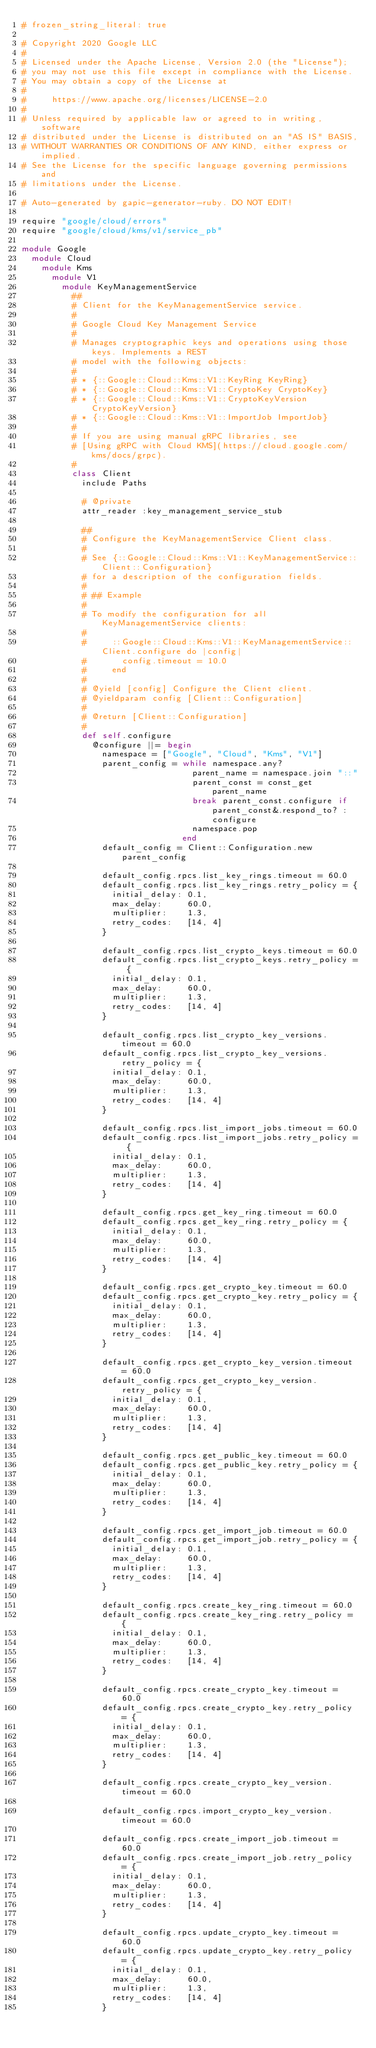<code> <loc_0><loc_0><loc_500><loc_500><_Ruby_># frozen_string_literal: true

# Copyright 2020 Google LLC
#
# Licensed under the Apache License, Version 2.0 (the "License");
# you may not use this file except in compliance with the License.
# You may obtain a copy of the License at
#
#     https://www.apache.org/licenses/LICENSE-2.0
#
# Unless required by applicable law or agreed to in writing, software
# distributed under the License is distributed on an "AS IS" BASIS,
# WITHOUT WARRANTIES OR CONDITIONS OF ANY KIND, either express or implied.
# See the License for the specific language governing permissions and
# limitations under the License.

# Auto-generated by gapic-generator-ruby. DO NOT EDIT!

require "google/cloud/errors"
require "google/cloud/kms/v1/service_pb"

module Google
  module Cloud
    module Kms
      module V1
        module KeyManagementService
          ##
          # Client for the KeyManagementService service.
          #
          # Google Cloud Key Management Service
          #
          # Manages cryptographic keys and operations using those keys. Implements a REST
          # model with the following objects:
          #
          # * {::Google::Cloud::Kms::V1::KeyRing KeyRing}
          # * {::Google::Cloud::Kms::V1::CryptoKey CryptoKey}
          # * {::Google::Cloud::Kms::V1::CryptoKeyVersion CryptoKeyVersion}
          # * {::Google::Cloud::Kms::V1::ImportJob ImportJob}
          #
          # If you are using manual gRPC libraries, see
          # [Using gRPC with Cloud KMS](https://cloud.google.com/kms/docs/grpc).
          #
          class Client
            include Paths

            # @private
            attr_reader :key_management_service_stub

            ##
            # Configure the KeyManagementService Client class.
            #
            # See {::Google::Cloud::Kms::V1::KeyManagementService::Client::Configuration}
            # for a description of the configuration fields.
            #
            # ## Example
            #
            # To modify the configuration for all KeyManagementService clients:
            #
            #     ::Google::Cloud::Kms::V1::KeyManagementService::Client.configure do |config|
            #       config.timeout = 10.0
            #     end
            #
            # @yield [config] Configure the Client client.
            # @yieldparam config [Client::Configuration]
            #
            # @return [Client::Configuration]
            #
            def self.configure
              @configure ||= begin
                namespace = ["Google", "Cloud", "Kms", "V1"]
                parent_config = while namespace.any?
                                  parent_name = namespace.join "::"
                                  parent_const = const_get parent_name
                                  break parent_const.configure if parent_const&.respond_to? :configure
                                  namespace.pop
                                end
                default_config = Client::Configuration.new parent_config

                default_config.rpcs.list_key_rings.timeout = 60.0
                default_config.rpcs.list_key_rings.retry_policy = {
                  initial_delay: 0.1,
                  max_delay:     60.0,
                  multiplier:    1.3,
                  retry_codes:   [14, 4]
                }

                default_config.rpcs.list_crypto_keys.timeout = 60.0
                default_config.rpcs.list_crypto_keys.retry_policy = {
                  initial_delay: 0.1,
                  max_delay:     60.0,
                  multiplier:    1.3,
                  retry_codes:   [14, 4]
                }

                default_config.rpcs.list_crypto_key_versions.timeout = 60.0
                default_config.rpcs.list_crypto_key_versions.retry_policy = {
                  initial_delay: 0.1,
                  max_delay:     60.0,
                  multiplier:    1.3,
                  retry_codes:   [14, 4]
                }

                default_config.rpcs.list_import_jobs.timeout = 60.0
                default_config.rpcs.list_import_jobs.retry_policy = {
                  initial_delay: 0.1,
                  max_delay:     60.0,
                  multiplier:    1.3,
                  retry_codes:   [14, 4]
                }

                default_config.rpcs.get_key_ring.timeout = 60.0
                default_config.rpcs.get_key_ring.retry_policy = {
                  initial_delay: 0.1,
                  max_delay:     60.0,
                  multiplier:    1.3,
                  retry_codes:   [14, 4]
                }

                default_config.rpcs.get_crypto_key.timeout = 60.0
                default_config.rpcs.get_crypto_key.retry_policy = {
                  initial_delay: 0.1,
                  max_delay:     60.0,
                  multiplier:    1.3,
                  retry_codes:   [14, 4]
                }

                default_config.rpcs.get_crypto_key_version.timeout = 60.0
                default_config.rpcs.get_crypto_key_version.retry_policy = {
                  initial_delay: 0.1,
                  max_delay:     60.0,
                  multiplier:    1.3,
                  retry_codes:   [14, 4]
                }

                default_config.rpcs.get_public_key.timeout = 60.0
                default_config.rpcs.get_public_key.retry_policy = {
                  initial_delay: 0.1,
                  max_delay:     60.0,
                  multiplier:    1.3,
                  retry_codes:   [14, 4]
                }

                default_config.rpcs.get_import_job.timeout = 60.0
                default_config.rpcs.get_import_job.retry_policy = {
                  initial_delay: 0.1,
                  max_delay:     60.0,
                  multiplier:    1.3,
                  retry_codes:   [14, 4]
                }

                default_config.rpcs.create_key_ring.timeout = 60.0
                default_config.rpcs.create_key_ring.retry_policy = {
                  initial_delay: 0.1,
                  max_delay:     60.0,
                  multiplier:    1.3,
                  retry_codes:   [14, 4]
                }

                default_config.rpcs.create_crypto_key.timeout = 60.0
                default_config.rpcs.create_crypto_key.retry_policy = {
                  initial_delay: 0.1,
                  max_delay:     60.0,
                  multiplier:    1.3,
                  retry_codes:   [14, 4]
                }

                default_config.rpcs.create_crypto_key_version.timeout = 60.0

                default_config.rpcs.import_crypto_key_version.timeout = 60.0

                default_config.rpcs.create_import_job.timeout = 60.0
                default_config.rpcs.create_import_job.retry_policy = {
                  initial_delay: 0.1,
                  max_delay:     60.0,
                  multiplier:    1.3,
                  retry_codes:   [14, 4]
                }

                default_config.rpcs.update_crypto_key.timeout = 60.0
                default_config.rpcs.update_crypto_key.retry_policy = {
                  initial_delay: 0.1,
                  max_delay:     60.0,
                  multiplier:    1.3,
                  retry_codes:   [14, 4]
                }
</code> 